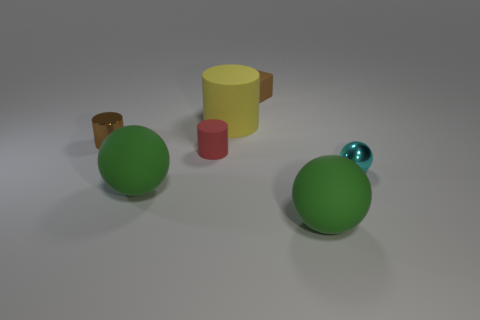Add 1 brown cylinders. How many objects exist? 8 Subtract all balls. How many objects are left? 4 Add 5 green objects. How many green objects are left? 7 Add 4 large green shiny things. How many large green shiny things exist? 4 Subtract 0 green blocks. How many objects are left? 7 Subtract all blue shiny blocks. Subtract all small rubber cubes. How many objects are left? 6 